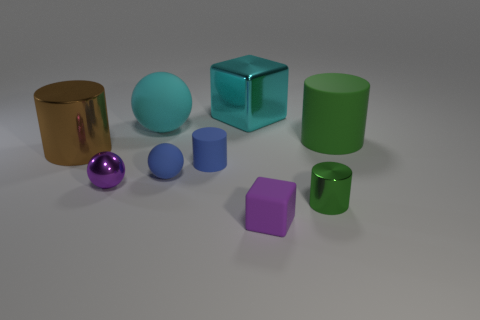How big is the purple rubber object?
Offer a terse response. Small. What number of matte things are either large brown things or cyan cubes?
Offer a very short reply. 0. Is the number of tiny blue matte cylinders less than the number of things?
Make the answer very short. Yes. How many other objects are there of the same material as the big brown object?
Provide a short and direct response. 3. The green shiny object that is the same shape as the brown object is what size?
Offer a very short reply. Small. Does the purple thing on the left side of the large rubber ball have the same material as the green thing behind the big brown shiny thing?
Provide a short and direct response. No. Is the number of small rubber cubes behind the purple metallic sphere less than the number of small green cylinders?
Your answer should be very brief. Yes. Is there any other thing that has the same shape as the brown thing?
Offer a very short reply. Yes. There is another small thing that is the same shape as the small purple metallic object; what is its color?
Ensure brevity in your answer.  Blue. Does the purple object that is right of the cyan metal thing have the same size as the blue matte cylinder?
Provide a succinct answer. Yes. 